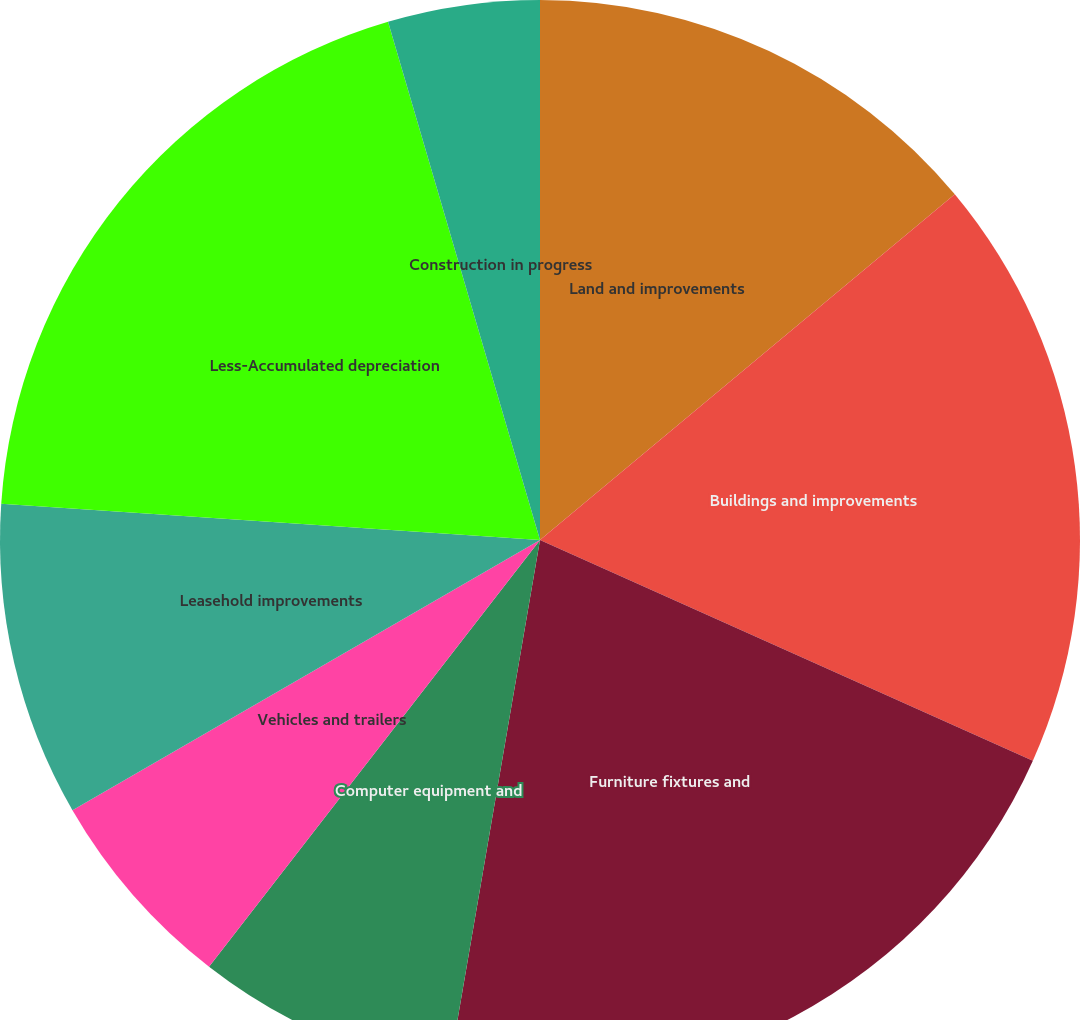Convert chart to OTSL. <chart><loc_0><loc_0><loc_500><loc_500><pie_chart><fcel>Land and improvements<fcel>Buildings and improvements<fcel>Furniture fixtures and<fcel>Computer equipment and<fcel>Vehicles and trailers<fcel>Leasehold improvements<fcel>Less-Accumulated depreciation<fcel>Construction in progress<nl><fcel>13.94%<fcel>17.76%<fcel>21.01%<fcel>7.79%<fcel>6.16%<fcel>9.41%<fcel>19.39%<fcel>4.54%<nl></chart> 